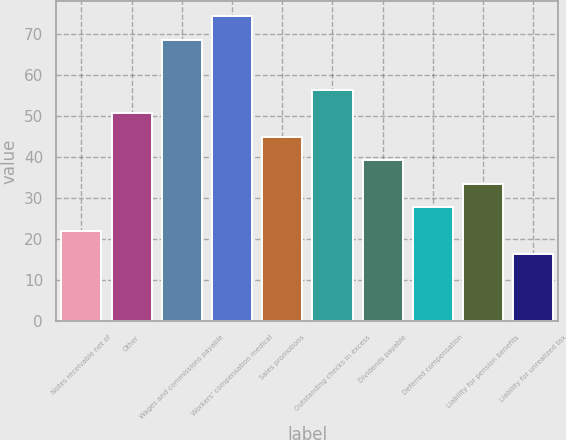Convert chart. <chart><loc_0><loc_0><loc_500><loc_500><bar_chart><fcel>Notes receivable net of<fcel>Other<fcel>Wages and commissions payable<fcel>Workers' compensation medical<fcel>Sales promotions<fcel>Outstanding checks in excess<fcel>Dividends payable<fcel>Deferred compensation<fcel>Liability for pension benefits<fcel>Liability for unrealized tax<nl><fcel>22.04<fcel>50.74<fcel>68.7<fcel>74.44<fcel>45<fcel>56.48<fcel>39.26<fcel>27.78<fcel>33.52<fcel>16.3<nl></chart> 